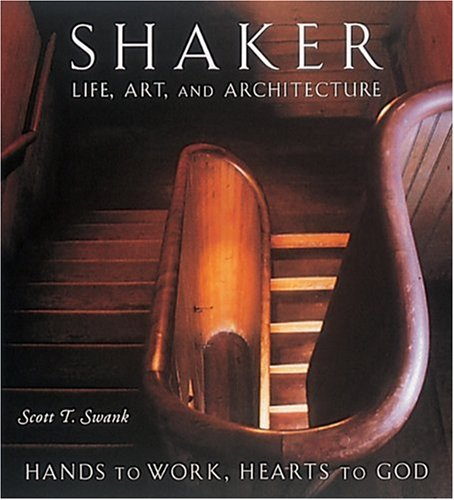What is the genre of this book? This book falls under the genre of 'Christian Books & Bibles,' specifically focusing on the religious and communal practices of the Shaker sect in America. 